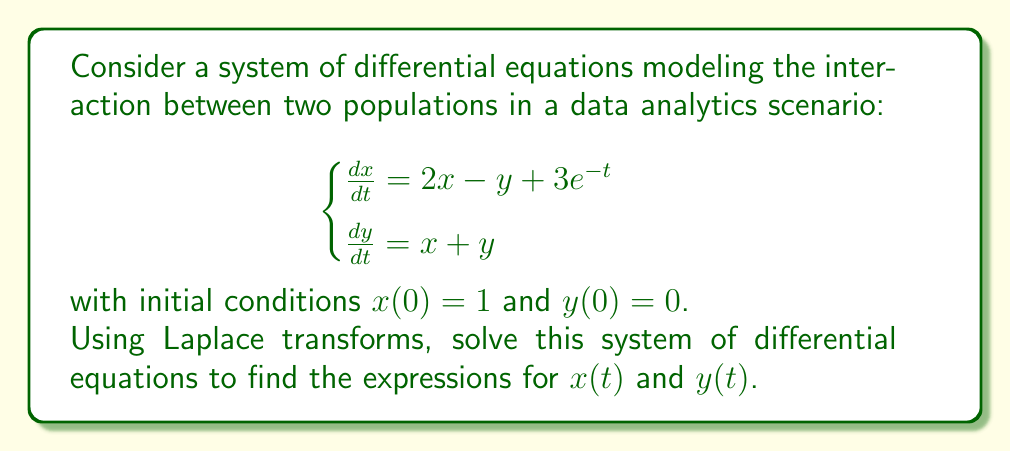Help me with this question. Let's solve this step-by-step using Laplace transforms:

1) Take the Laplace transform of both equations:
   $$\begin{cases}
   sX(s) - x(0) = 2X(s) - Y(s) + \frac{3}{s+1} \\
   sY(s) - y(0) = X(s) + Y(s)
   \end{cases}$$

2) Substitute the initial conditions:
   $$\begin{cases}
   sX(s) - 1 = 2X(s) - Y(s) + \frac{3}{s+1} \\
   sY(s) = X(s) + Y(s)
   \end{cases}$$

3) Rearrange the equations:
   $$\begin{cases}
   (s-2)X(s) + Y(s) = 1 + \frac{3}{s+1} \\
   -X(s) + (s-1)Y(s) = 0
   \end{cases}$$

4) Solve this system of algebraic equations:
   From the second equation: $X(s) = (s-1)Y(s)$
   Substitute into the first equation:
   $$(s-2)(s-1)Y(s) + Y(s) = 1 + \frac{3}{s+1}$$
   $$(s^2-3s+2)Y(s) = 1 + \frac{3}{s+1}$$
   $$Y(s) = \frac{1}{s^2-3s+2} + \frac{3}{(s^2-3s+2)(s+1)}$$

5) Partial fraction decomposition:
   $$Y(s) = \frac{A}{s-1} + \frac{B}{s-2} + \frac{C}{s+1}$$
   Solving for A, B, and C:
   $$Y(s) = \frac{1}{s-1} - \frac{1}{s-2} + \frac{3}{s+1}$$

6) Take the inverse Laplace transform:
   $$y(t) = e^t - e^{2t} + 3e^{-t}$$

7) To find $x(t)$, use $X(s) = (s-1)Y(s)$:
   $$X(s) = (s-1)(\frac{1}{s-1} - \frac{1}{s-2} + \frac{3}{s+1})$$
   $$X(s) = 1 - \frac{s-1}{s-2} + \frac{3(s-1)}{s+1}$$
   $$X(s) = 1 - 1 - \frac{1}{s-2} + 3 - \frac{6}{s+1}$$
   $$X(s) = 3 - \frac{1}{s-2} - \frac{6}{s+1}$$

8) Take the inverse Laplace transform:
   $$x(t) = 3 - e^{2t} - 6e^{-t}$$
Answer: $x(t) = 3 - e^{2t} - 6e^{-t}$, $y(t) = e^t - e^{2t} + 3e^{-t}$ 